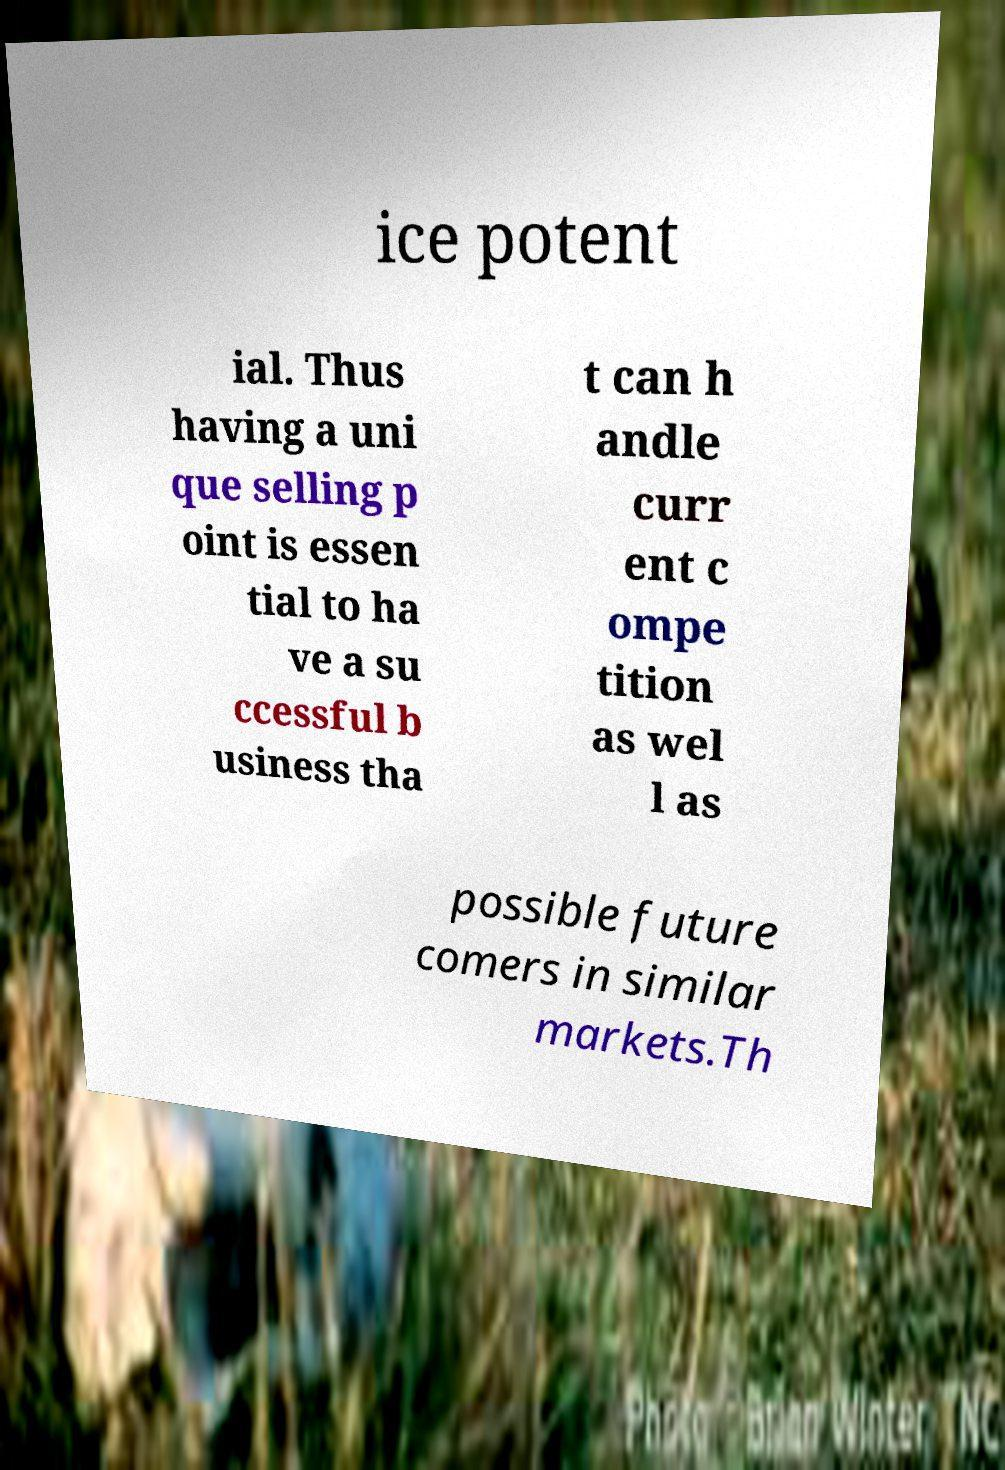There's text embedded in this image that I need extracted. Can you transcribe it verbatim? ice potent ial. Thus having a uni que selling p oint is essen tial to ha ve a su ccessful b usiness tha t can h andle curr ent c ompe tition as wel l as possible future comers in similar markets.Th 